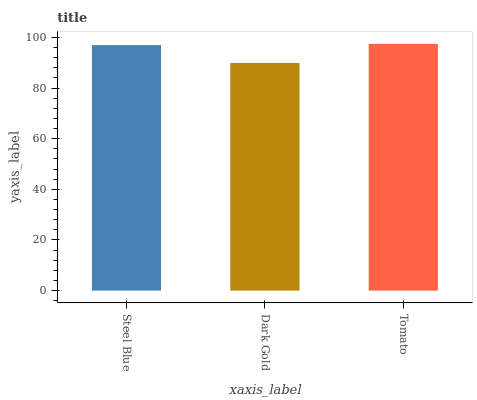Is Dark Gold the minimum?
Answer yes or no. Yes. Is Tomato the maximum?
Answer yes or no. Yes. Is Tomato the minimum?
Answer yes or no. No. Is Dark Gold the maximum?
Answer yes or no. No. Is Tomato greater than Dark Gold?
Answer yes or no. Yes. Is Dark Gold less than Tomato?
Answer yes or no. Yes. Is Dark Gold greater than Tomato?
Answer yes or no. No. Is Tomato less than Dark Gold?
Answer yes or no. No. Is Steel Blue the high median?
Answer yes or no. Yes. Is Steel Blue the low median?
Answer yes or no. Yes. Is Dark Gold the high median?
Answer yes or no. No. Is Tomato the low median?
Answer yes or no. No. 